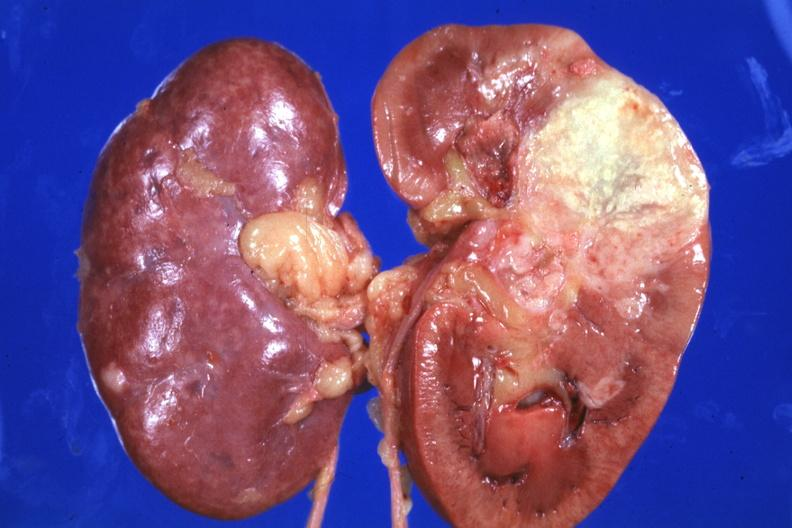where is this?
Answer the question using a single word or phrase. Urinary 